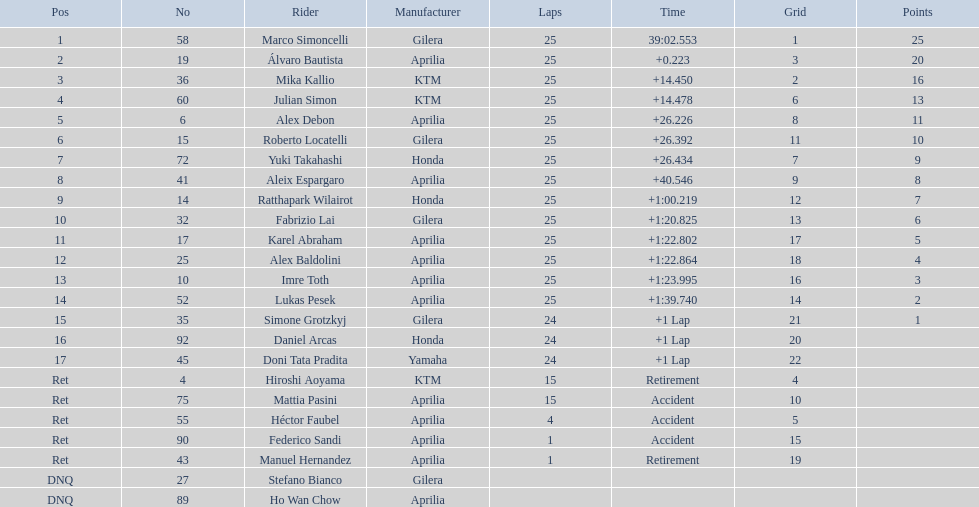Who were all of the riders? Marco Simoncelli, Álvaro Bautista, Mika Kallio, Julian Simon, Alex Debon, Roberto Locatelli, Yuki Takahashi, Aleix Espargaro, Ratthapark Wilairot, Fabrizio Lai, Karel Abraham, Alex Baldolini, Imre Toth, Lukas Pesek, Simone Grotzkyj, Daniel Arcas, Doni Tata Pradita, Hiroshi Aoyama, Mattia Pasini, Héctor Faubel, Federico Sandi, Manuel Hernandez, Stefano Bianco, Ho Wan Chow. How many laps did they complete? 25, 25, 25, 25, 25, 25, 25, 25, 25, 25, 25, 25, 25, 25, 24, 24, 24, 15, 15, 4, 1, 1, , . Between marco simoncelli and hiroshi aoyama, who had more laps? Marco Simoncelli. 